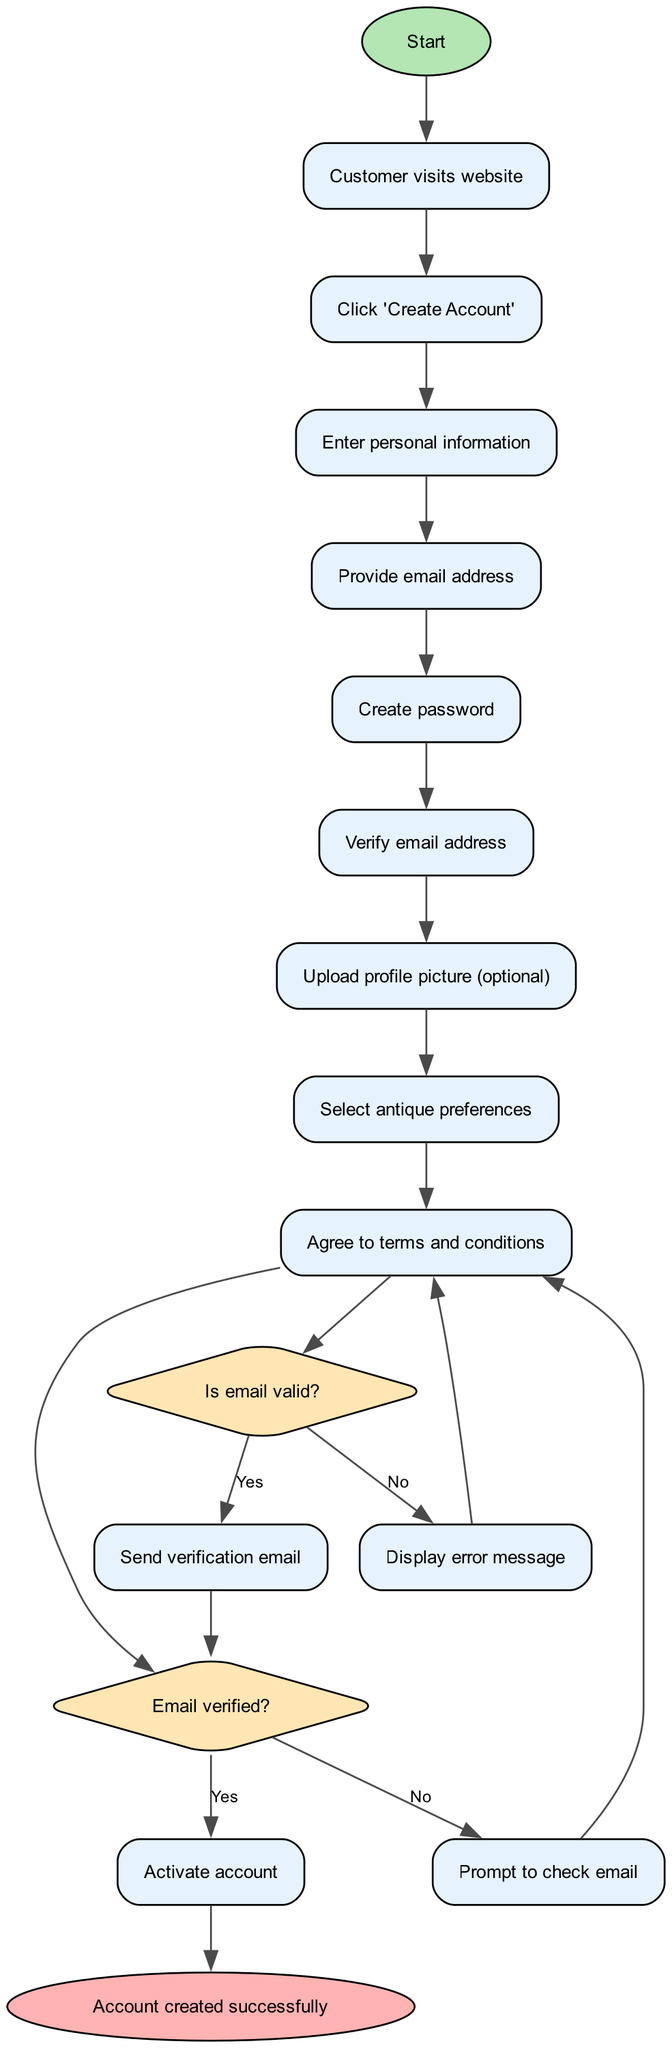What is the first activity in the registration process? The first activity listed in the diagram is "Click 'Create Account'", which is the action that initiates the registration process. This is indicated by the first connection from the start node.
Answer: Click 'Create Account' How many activities are there in the diagram? To find the number of activities, we count the items in the "activities" list provided, which totals to eight activities.
Answer: Eight What happens if the email address provided is not valid? According to the decision point concerning the validity of the email, if it is not valid, the user receives a "Display error message." Thus, the flow diverts from the verification process and prompts a corrective action.
Answer: Display error message What is the final node of the diagram? The final node is labeled "Account created successfully," which indicates the conclusion of the registration process. This node represents the end result after successful account verification and other processes.
Answer: Account created successfully What decision follows the verification of the email address? After the email is verified, the next decision is whether the account should be activated. If it is verified, the account gets activated; if not, the user is prompted to check their email. This follows logically from the outcome of the previous decision.
Answer: Activate account How many decision points are present in the diagram? There are two decision points in the diagram: the first concerning the validity of the email and the second about whether the email has been verified.
Answer: Two If the email is valid, what will occur next? If the email is valid, a verification email is sent. This is a direct action that follows the positive outcome of the validity check decision.
Answer: Send verification email What activity takes place after the user agrees to the terms and conditions? Once the user agrees to the terms and conditions, the flow moves to the decision point regarding email verification. This indicates the sequence of actions leading towards the final account creation step.
Answer: Proceed to email verification 